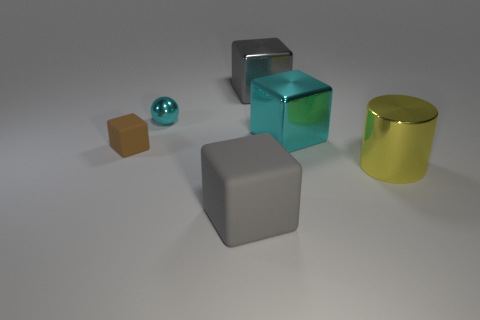Add 2 gray rubber cubes. How many objects exist? 8 Subtract all blocks. How many objects are left? 2 Add 3 big things. How many big things are left? 7 Add 3 large blocks. How many large blocks exist? 6 Subtract 0 blue cylinders. How many objects are left? 6 Subtract all big yellow objects. Subtract all cyan metal objects. How many objects are left? 3 